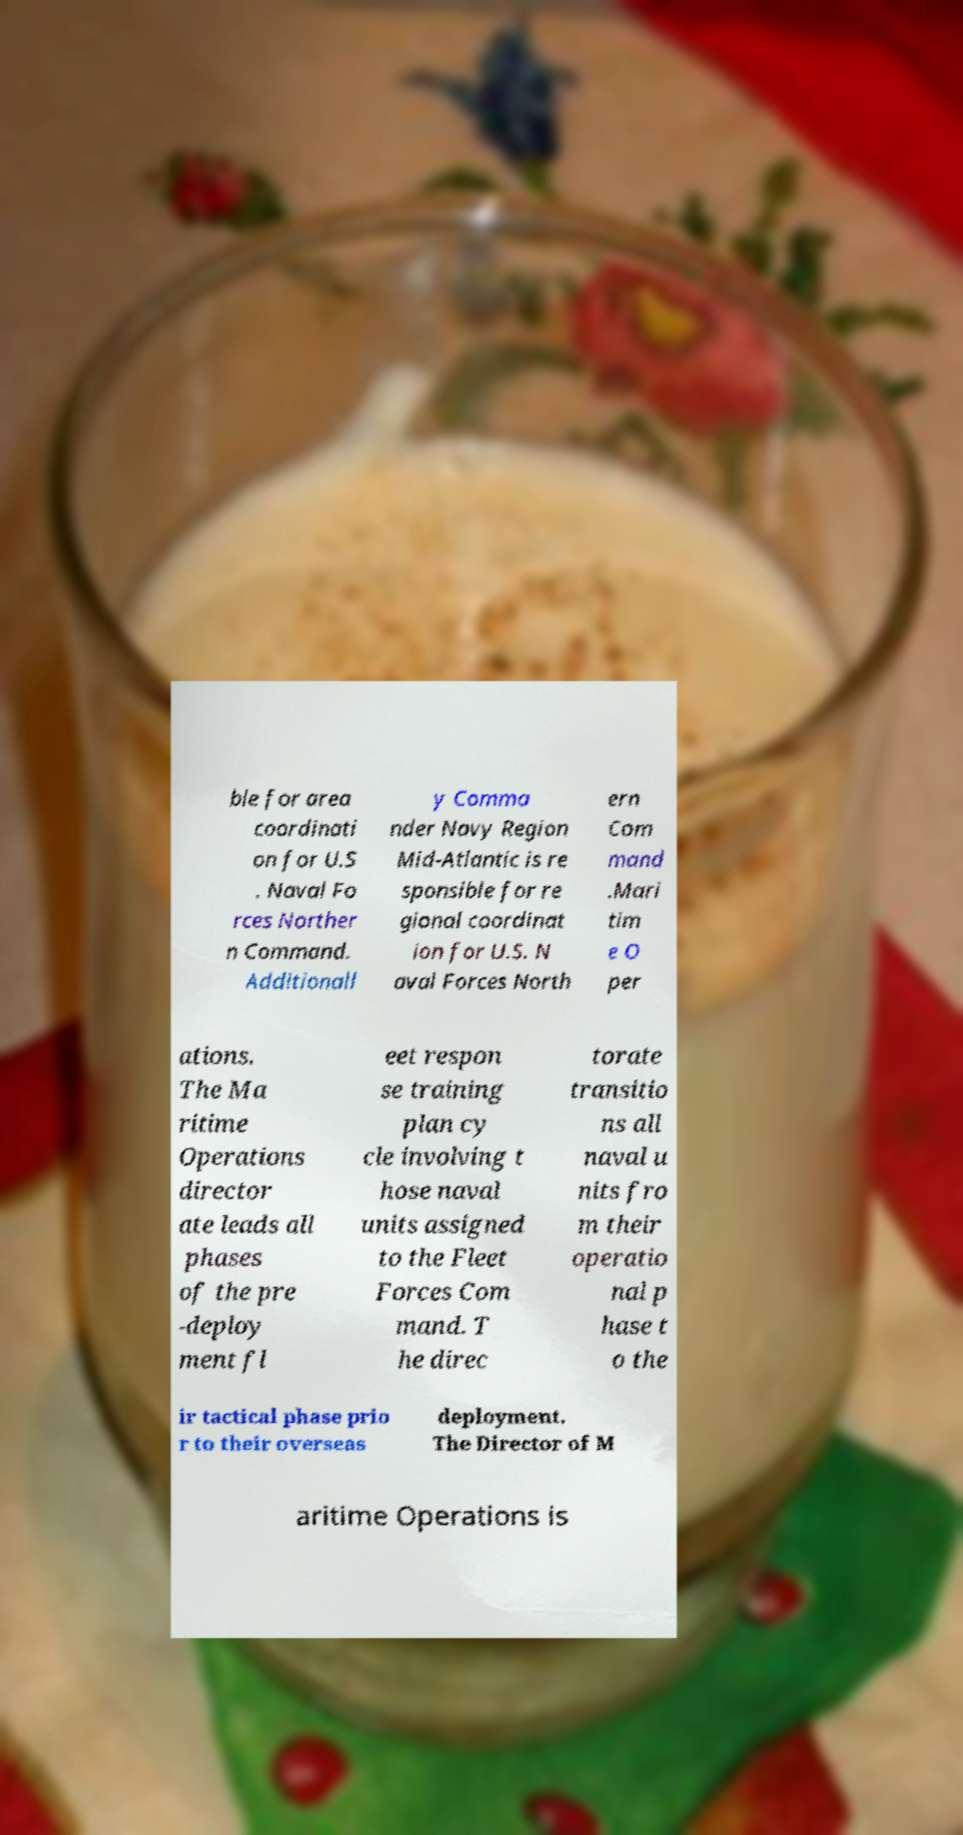I need the written content from this picture converted into text. Can you do that? ble for area coordinati on for U.S . Naval Fo rces Norther n Command. Additionall y Comma nder Navy Region Mid-Atlantic is re sponsible for re gional coordinat ion for U.S. N aval Forces North ern Com mand .Mari tim e O per ations. The Ma ritime Operations director ate leads all phases of the pre -deploy ment fl eet respon se training plan cy cle involving t hose naval units assigned to the Fleet Forces Com mand. T he direc torate transitio ns all naval u nits fro m their operatio nal p hase t o the ir tactical phase prio r to their overseas deployment. The Director of M aritime Operations is 